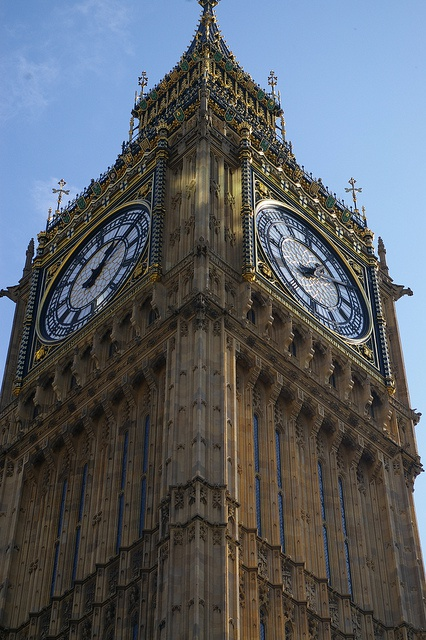Describe the objects in this image and their specific colors. I can see clock in gray, black, darkgray, and lightgray tones and clock in gray and black tones in this image. 